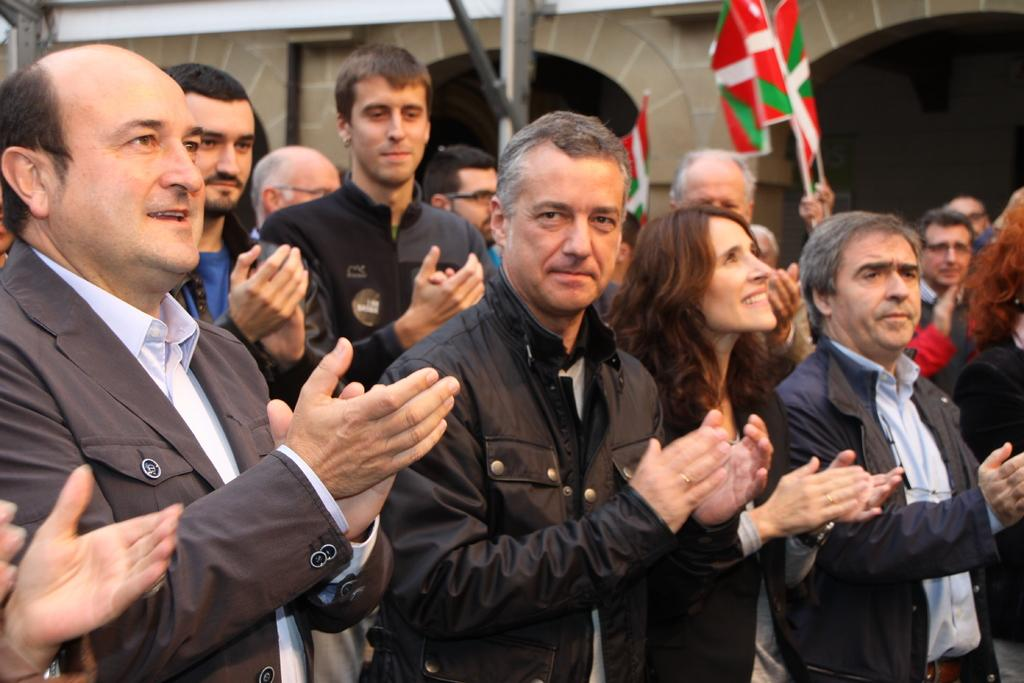How many people are present in the image? There are many people standing in the image. What are the people doing in the image? The people are smiling and clapping their hands. Are there any objects or items being held by the people? Yes, some people are holding flags in their hands. What can be seen in the background of the image? There is a wall of a house in the background of the image. What type of bear can be seen in the image? There is no bear present in the image. What does the image smell like? The image does not have a smell, as it is a visual representation. 